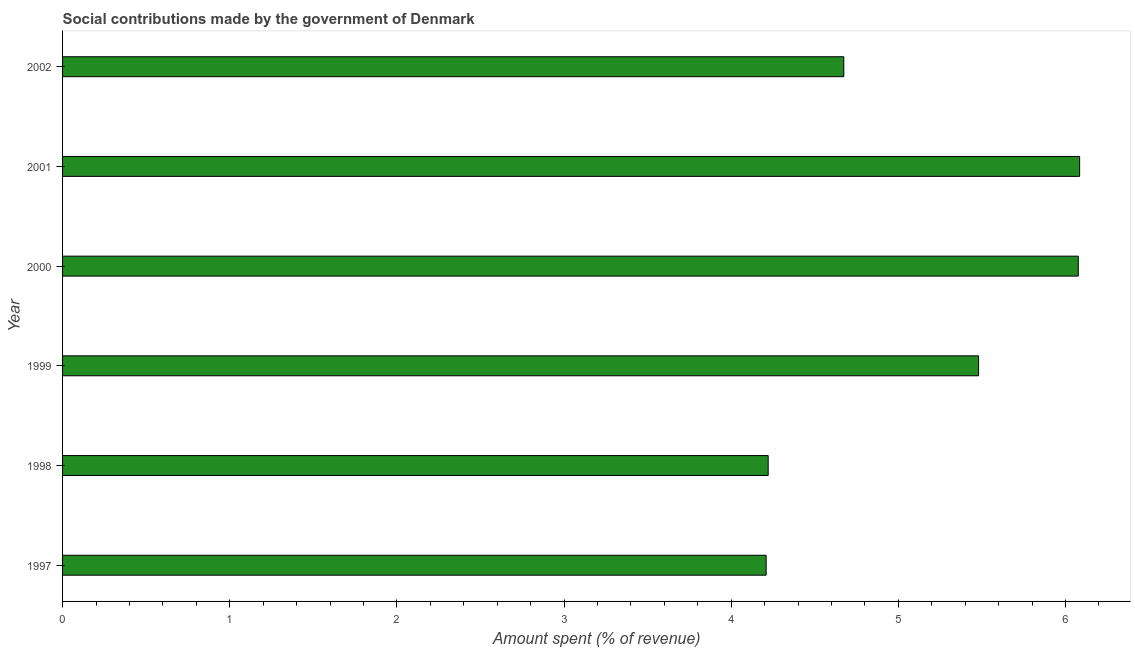Does the graph contain any zero values?
Give a very brief answer. No. What is the title of the graph?
Offer a very short reply. Social contributions made by the government of Denmark. What is the label or title of the X-axis?
Offer a very short reply. Amount spent (% of revenue). What is the amount spent in making social contributions in 1999?
Make the answer very short. 5.48. Across all years, what is the maximum amount spent in making social contributions?
Offer a terse response. 6.08. Across all years, what is the minimum amount spent in making social contributions?
Offer a very short reply. 4.21. What is the sum of the amount spent in making social contributions?
Offer a very short reply. 30.75. What is the difference between the amount spent in making social contributions in 1998 and 2000?
Keep it short and to the point. -1.85. What is the average amount spent in making social contributions per year?
Make the answer very short. 5.12. What is the median amount spent in making social contributions?
Make the answer very short. 5.08. In how many years, is the amount spent in making social contributions greater than 1.4 %?
Provide a short and direct response. 6. What is the ratio of the amount spent in making social contributions in 1998 to that in 2002?
Your response must be concise. 0.9. Is the difference between the amount spent in making social contributions in 1997 and 1998 greater than the difference between any two years?
Keep it short and to the point. No. What is the difference between the highest and the second highest amount spent in making social contributions?
Offer a terse response. 0.01. Is the sum of the amount spent in making social contributions in 1999 and 2000 greater than the maximum amount spent in making social contributions across all years?
Offer a very short reply. Yes. What is the difference between the highest and the lowest amount spent in making social contributions?
Make the answer very short. 1.88. How many years are there in the graph?
Your answer should be compact. 6. What is the difference between two consecutive major ticks on the X-axis?
Provide a succinct answer. 1. Are the values on the major ticks of X-axis written in scientific E-notation?
Provide a short and direct response. No. What is the Amount spent (% of revenue) in 1997?
Keep it short and to the point. 4.21. What is the Amount spent (% of revenue) of 1998?
Give a very brief answer. 4.22. What is the Amount spent (% of revenue) of 1999?
Offer a terse response. 5.48. What is the Amount spent (% of revenue) in 2000?
Provide a short and direct response. 6.08. What is the Amount spent (% of revenue) of 2001?
Offer a very short reply. 6.08. What is the Amount spent (% of revenue) of 2002?
Your answer should be very brief. 4.67. What is the difference between the Amount spent (% of revenue) in 1997 and 1998?
Your response must be concise. -0.01. What is the difference between the Amount spent (% of revenue) in 1997 and 1999?
Make the answer very short. -1.27. What is the difference between the Amount spent (% of revenue) in 1997 and 2000?
Keep it short and to the point. -1.87. What is the difference between the Amount spent (% of revenue) in 1997 and 2001?
Ensure brevity in your answer.  -1.88. What is the difference between the Amount spent (% of revenue) in 1997 and 2002?
Provide a short and direct response. -0.46. What is the difference between the Amount spent (% of revenue) in 1998 and 1999?
Ensure brevity in your answer.  -1.26. What is the difference between the Amount spent (% of revenue) in 1998 and 2000?
Your answer should be very brief. -1.86. What is the difference between the Amount spent (% of revenue) in 1998 and 2001?
Provide a succinct answer. -1.86. What is the difference between the Amount spent (% of revenue) in 1998 and 2002?
Provide a succinct answer. -0.45. What is the difference between the Amount spent (% of revenue) in 1999 and 2000?
Make the answer very short. -0.6. What is the difference between the Amount spent (% of revenue) in 1999 and 2001?
Offer a terse response. -0.6. What is the difference between the Amount spent (% of revenue) in 1999 and 2002?
Your response must be concise. 0.81. What is the difference between the Amount spent (% of revenue) in 2000 and 2001?
Keep it short and to the point. -0.01. What is the difference between the Amount spent (% of revenue) in 2000 and 2002?
Provide a short and direct response. 1.4. What is the difference between the Amount spent (% of revenue) in 2001 and 2002?
Ensure brevity in your answer.  1.41. What is the ratio of the Amount spent (% of revenue) in 1997 to that in 1999?
Make the answer very short. 0.77. What is the ratio of the Amount spent (% of revenue) in 1997 to that in 2000?
Give a very brief answer. 0.69. What is the ratio of the Amount spent (% of revenue) in 1997 to that in 2001?
Provide a succinct answer. 0.69. What is the ratio of the Amount spent (% of revenue) in 1997 to that in 2002?
Your answer should be very brief. 0.9. What is the ratio of the Amount spent (% of revenue) in 1998 to that in 1999?
Your response must be concise. 0.77. What is the ratio of the Amount spent (% of revenue) in 1998 to that in 2000?
Your answer should be compact. 0.69. What is the ratio of the Amount spent (% of revenue) in 1998 to that in 2001?
Offer a terse response. 0.69. What is the ratio of the Amount spent (% of revenue) in 1998 to that in 2002?
Provide a short and direct response. 0.9. What is the ratio of the Amount spent (% of revenue) in 1999 to that in 2000?
Make the answer very short. 0.9. What is the ratio of the Amount spent (% of revenue) in 1999 to that in 2001?
Offer a terse response. 0.9. What is the ratio of the Amount spent (% of revenue) in 1999 to that in 2002?
Your answer should be compact. 1.17. What is the ratio of the Amount spent (% of revenue) in 2001 to that in 2002?
Ensure brevity in your answer.  1.3. 